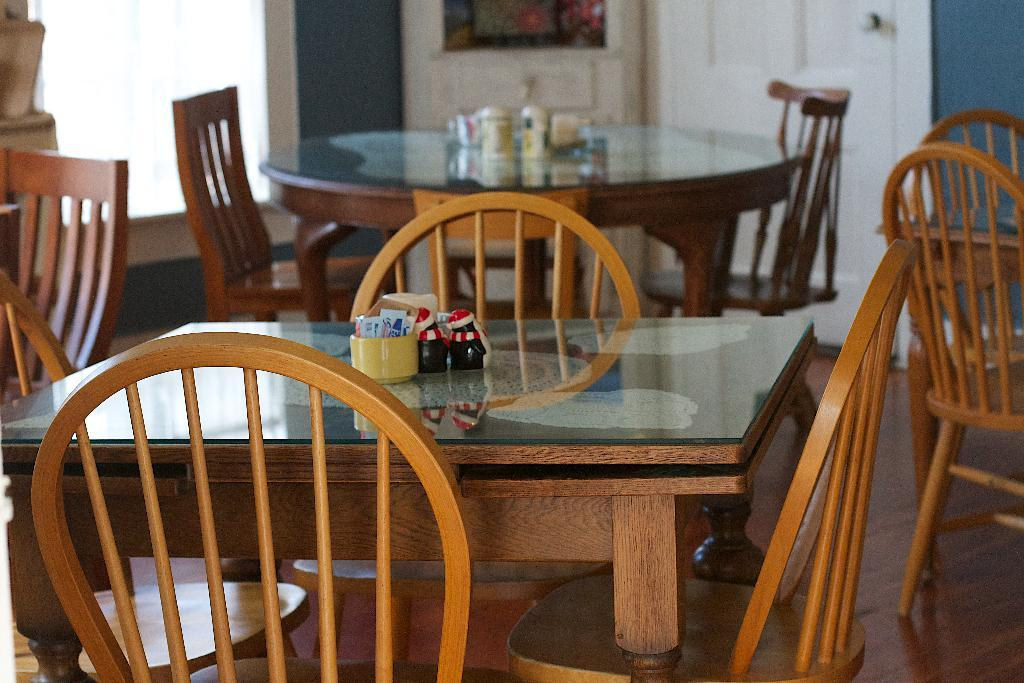What type of furniture is present in the image? There are chairs and tables in the image. What might be used for sitting or eating in the image? The chairs and tables in the image can be used for sitting or eating. What can be seen on the tables in the image? There are items on the tables in the image. What is hanging on the wall in the image? There is a photo frame on the wall in the image. What architectural feature is visible in the image? There is a door visible in the image. What type of land can be seen through the door in the image? There is no land visible through the door in the image; it is an interior scene. Can you tell me how many times the person in the photo frame has bitten their nails? There is no person visible in the photo frame in the image, so it is impossible to determine how many times they have bitten their nails. 